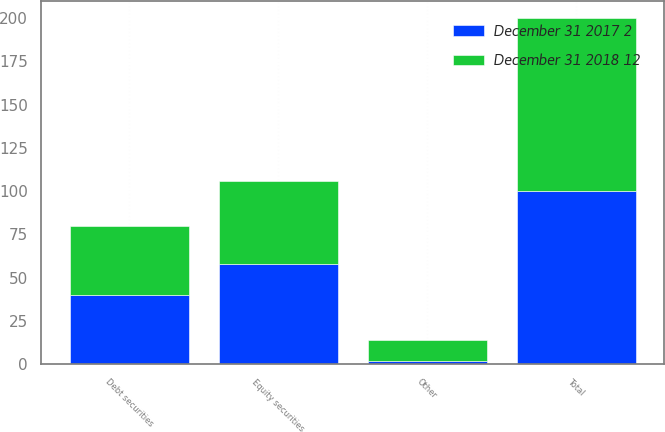Convert chart. <chart><loc_0><loc_0><loc_500><loc_500><stacked_bar_chart><ecel><fcel>Equity securities<fcel>Debt securities<fcel>Other<fcel>Total<nl><fcel>December 31 2018 12<fcel>48<fcel>40<fcel>12<fcel>100<nl><fcel>December 31 2017 2<fcel>58<fcel>40<fcel>2<fcel>100<nl></chart> 